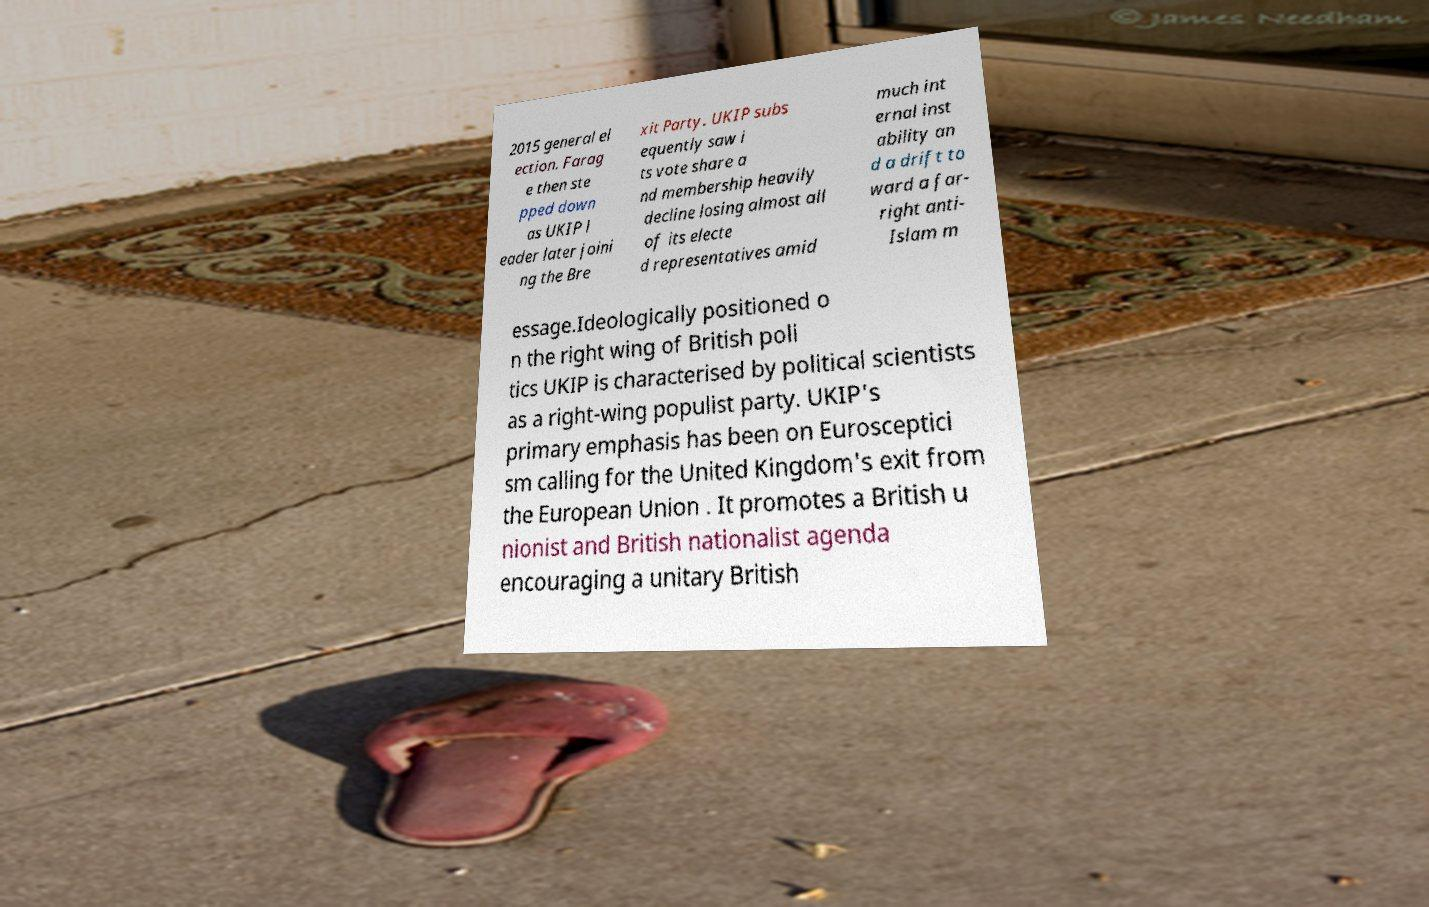Could you extract and type out the text from this image? 2015 general el ection. Farag e then ste pped down as UKIP l eader later joini ng the Bre xit Party. UKIP subs equently saw i ts vote share a nd membership heavily decline losing almost all of its electe d representatives amid much int ernal inst ability an d a drift to ward a far- right anti- Islam m essage.Ideologically positioned o n the right wing of British poli tics UKIP is characterised by political scientists as a right-wing populist party. UKIP's primary emphasis has been on Eurosceptici sm calling for the United Kingdom's exit from the European Union . It promotes a British u nionist and British nationalist agenda encouraging a unitary British 